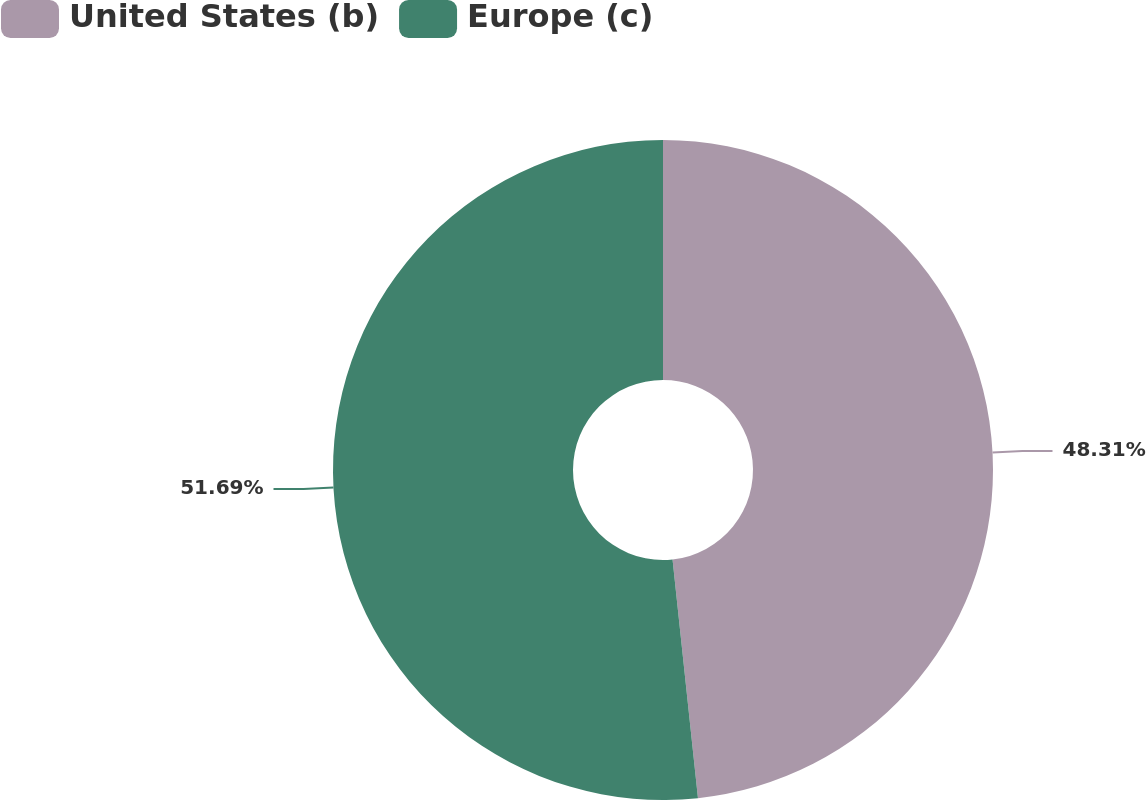Convert chart to OTSL. <chart><loc_0><loc_0><loc_500><loc_500><pie_chart><fcel>United States (b)<fcel>Europe (c)<nl><fcel>48.31%<fcel>51.69%<nl></chart> 